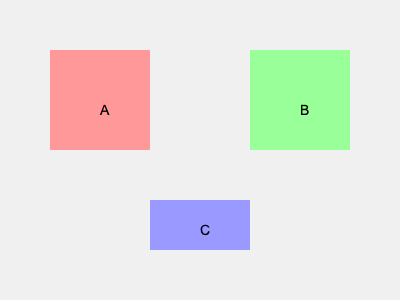In a scene where you need to create visual balance, three props (A, B, and C) are placed on the stage as shown. Which prop should be moved to the center to achieve the best visual composition according to the rule of thirds? To determine the best visual composition using the rule of thirds, we need to follow these steps:

1. Understand the rule of thirds: This principle divides the frame into a 3x3 grid, creating nine equal parts. The intersections of these lines are considered optimal focal points.

2. Analyze the current layout:
   - Prop A is in the top-left quadrant
   - Prop B is in the top-right quadrant
   - Prop C is at the bottom-center

3. Identify the center point: The center of the stage is where the horizontal and vertical center lines of the rule of thirds grid intersect.

4. Evaluate each prop's potential in the center:
   - Prop A or B: Moving either to the center would create an imbalance, as it would leave one side of the stage empty.
   - Prop C: Moving it to the center would create a balanced composition, as it's already horizontally centered but needs vertical adjustment.

5. Consider the visual weight: Prop C appears smaller than A and B, making it suitable for a central focal point without overpowering the composition.

6. Apply the rule of thirds: Placing Prop C at the intersection of the center lines adheres to the rule of thirds, creating a strong focal point.

Therefore, moving Prop C to the center would achieve the best visual composition according to the rule of thirds.
Answer: C 